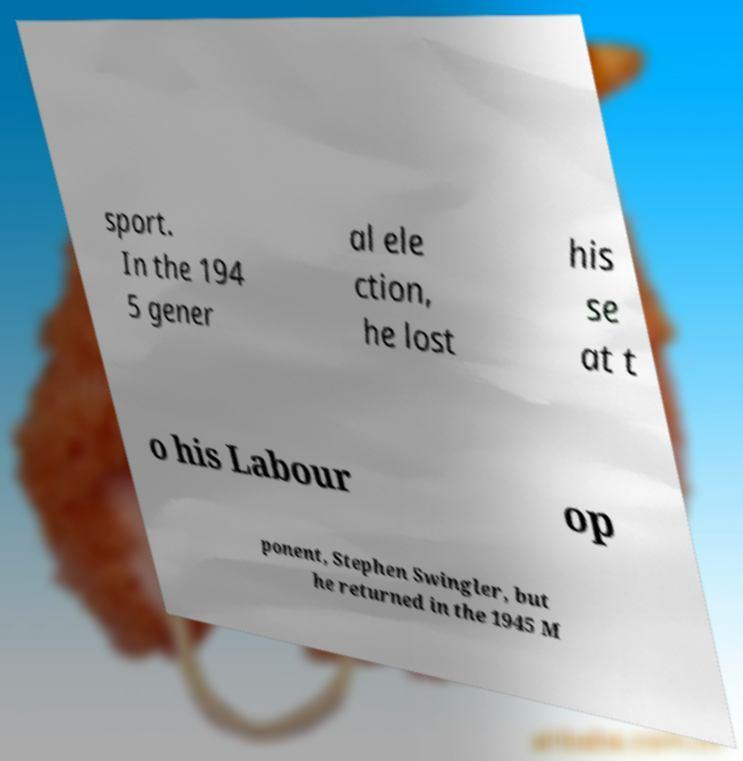What messages or text are displayed in this image? I need them in a readable, typed format. sport. In the 194 5 gener al ele ction, he lost his se at t o his Labour op ponent, Stephen Swingler, but he returned in the 1945 M 